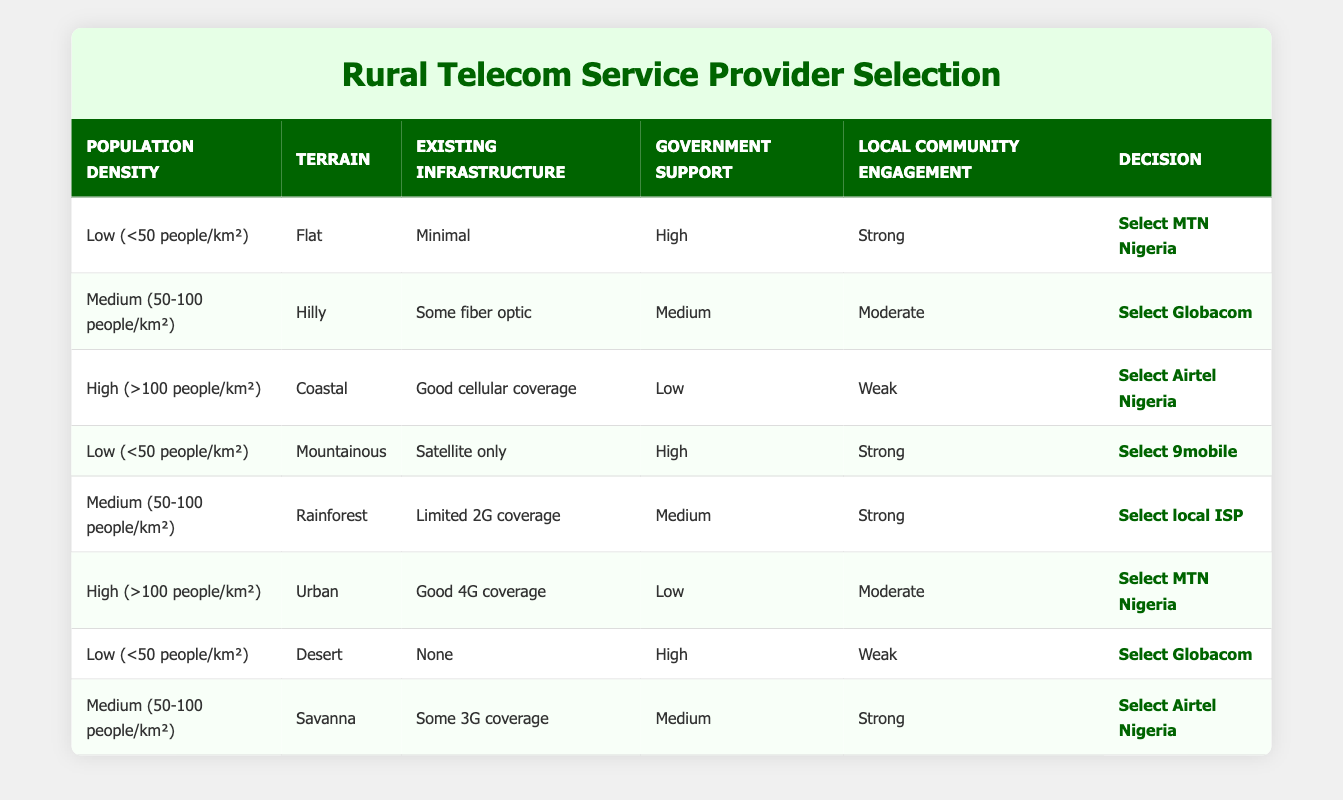What decision is made for areas with low population density and strong local community engagement? In the table, there are entries for low population density with strong local community engagement, specifically one listing flat terrain and another mountainous. Both of these conditions lead to selecting either MTN Nigeria or 9mobile.
Answer: Select MTN Nigeria or Select 9mobile Which service provider is chosen for medium population density in a rainforest with limited 2G coverage? The table states that in medium population density (50-100 people/km²) with rainforests and limited 2G coverage, the decision is to select a local ISP.
Answer: Select local ISP Is Airtel Nigeria chosen when government support is high? The entries in the table show that Airtel Nigeria is not selected when government support is high; instead, other providers are chosen under such conditions.
Answer: No What is the total count of unique service providers listed in the table? There are five unique service providers mentioned: MTN Nigeria, Globacom, Airtel Nigeria, 9mobile, and local ISP. Counting these provides the total of 5.
Answer: 5 For high population density with weak local community engagement, how many decisions are made? The table indicates that there is one decision under the condition of high population density with weak community engagement, selecting Airtel Nigeria.
Answer: 1 If a rural area has minimal existing infrastructure and high government support, which provider is selected? According to the table, a rural area with low population density, minimal existing infrastructure, and high government support results in the selection of MTN Nigeria.
Answer: Select MTN Nigeria Are there cases where Globacom is selected for areas with a low population density? The table does show a scenario where Globacom is selected for a low population density area; however, it is under specific conditions, such as terrain being desert and government support being high, indicating this choice does exist.
Answer: Yes What is the decision for a location with a medium population density, savanna terrain, and strong local community engagement? In the table, the decision for this specific condition (medium population density of 50-100 people/km², savanna terrain, strong local community engagement) is to select Airtel Nigeria.
Answer: Select Airtel Nigeria 